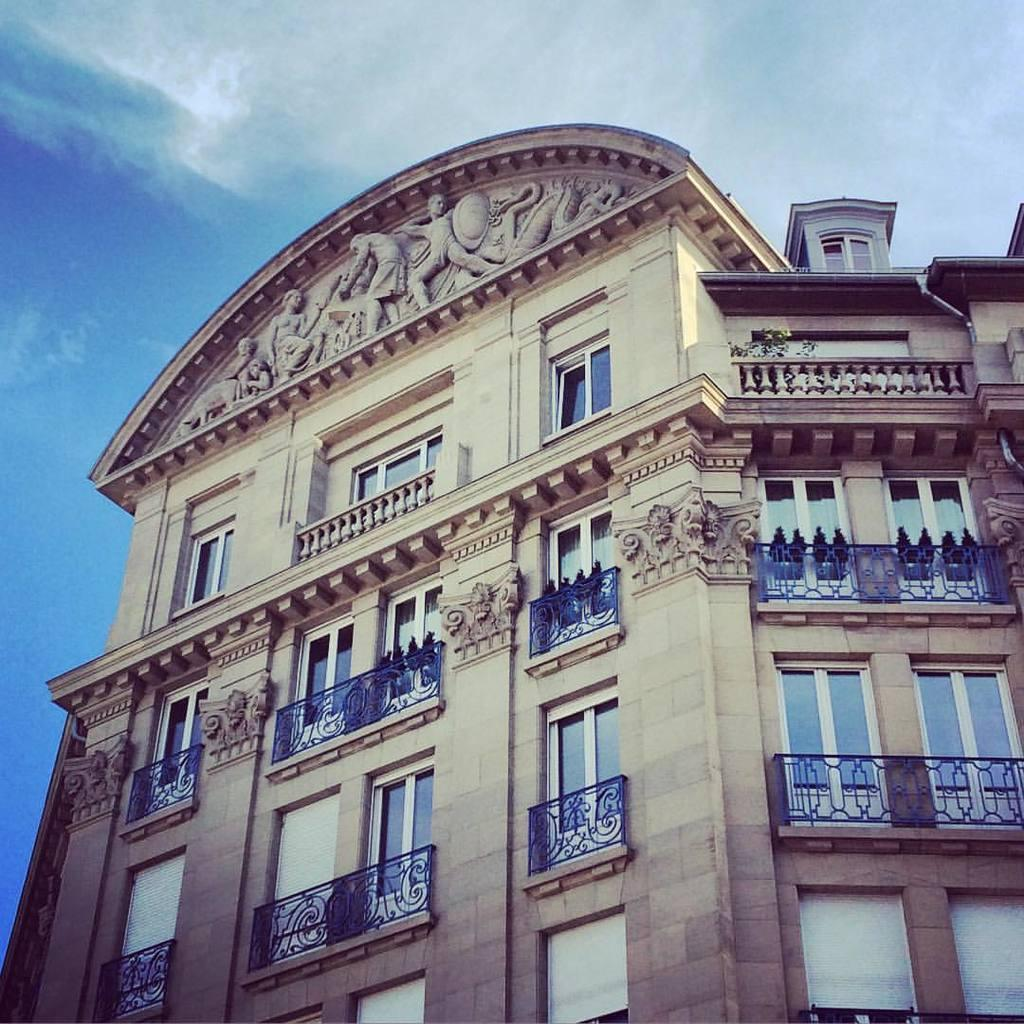What type of structure is present in the image? There is a building in the image. What features can be observed on the building? The building has windows and railing. What other objects are present in the image? There are sculptures in the image. What can be seen in the background of the image? There are clouds and the sky visible in the background of the image. What type of cherry is being used as a decoration on the building in the image? There is no cherry present in the image; it is a building with windows, railing, and sculptures. 